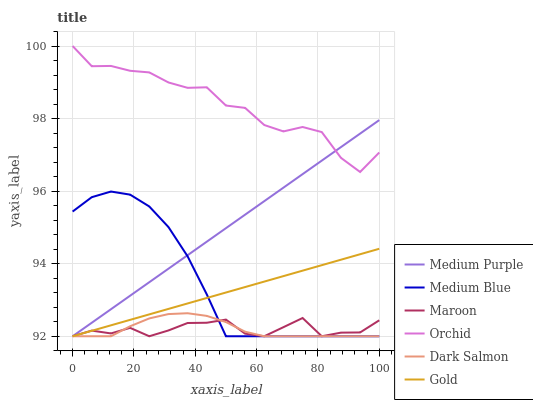Does Maroon have the minimum area under the curve?
Answer yes or no. Yes. Does Orchid have the maximum area under the curve?
Answer yes or no. Yes. Does Medium Blue have the minimum area under the curve?
Answer yes or no. No. Does Medium Blue have the maximum area under the curve?
Answer yes or no. No. Is Gold the smoothest?
Answer yes or no. Yes. Is Orchid the roughest?
Answer yes or no. Yes. Is Medium Blue the smoothest?
Answer yes or no. No. Is Medium Blue the roughest?
Answer yes or no. No. Does Gold have the lowest value?
Answer yes or no. Yes. Does Orchid have the lowest value?
Answer yes or no. No. Does Orchid have the highest value?
Answer yes or no. Yes. Does Medium Blue have the highest value?
Answer yes or no. No. Is Gold less than Orchid?
Answer yes or no. Yes. Is Orchid greater than Maroon?
Answer yes or no. Yes. Does Gold intersect Medium Blue?
Answer yes or no. Yes. Is Gold less than Medium Blue?
Answer yes or no. No. Is Gold greater than Medium Blue?
Answer yes or no. No. Does Gold intersect Orchid?
Answer yes or no. No. 